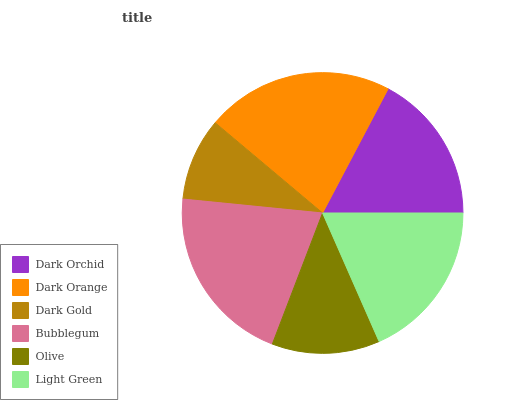Is Dark Gold the minimum?
Answer yes or no. Yes. Is Dark Orange the maximum?
Answer yes or no. Yes. Is Dark Orange the minimum?
Answer yes or no. No. Is Dark Gold the maximum?
Answer yes or no. No. Is Dark Orange greater than Dark Gold?
Answer yes or no. Yes. Is Dark Gold less than Dark Orange?
Answer yes or no. Yes. Is Dark Gold greater than Dark Orange?
Answer yes or no. No. Is Dark Orange less than Dark Gold?
Answer yes or no. No. Is Light Green the high median?
Answer yes or no. Yes. Is Dark Orchid the low median?
Answer yes or no. Yes. Is Dark Orchid the high median?
Answer yes or no. No. Is Dark Gold the low median?
Answer yes or no. No. 